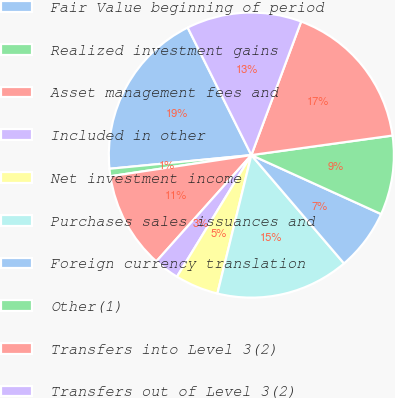Convert chart to OTSL. <chart><loc_0><loc_0><loc_500><loc_500><pie_chart><fcel>Fair Value beginning of period<fcel>Realized investment gains<fcel>Asset management fees and<fcel>Included in other<fcel>Net investment income<fcel>Purchases sales issuances and<fcel>Foreign currency translation<fcel>Other(1)<fcel>Transfers into Level 3(2)<fcel>Transfers out of Level 3(2)<nl><fcel>19.16%<fcel>0.84%<fcel>11.02%<fcel>2.87%<fcel>4.91%<fcel>15.09%<fcel>6.95%<fcel>8.98%<fcel>17.13%<fcel>13.05%<nl></chart> 